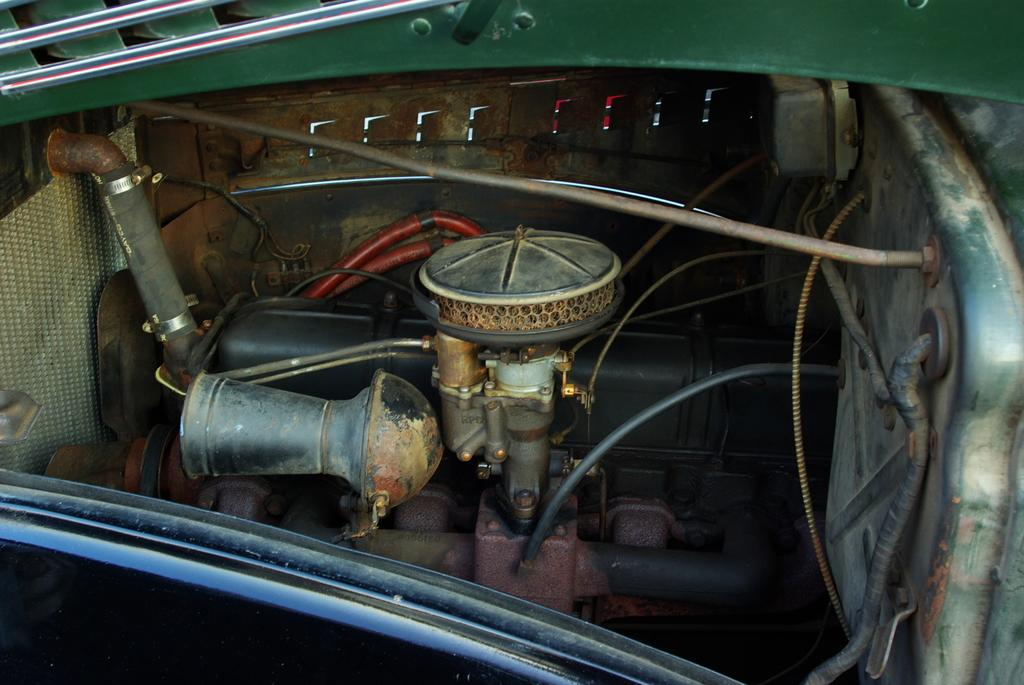What is the main subject of the image? The main subject of the image is an engine of a car. Can you describe another component visible in the image? Yes, there is a radiator on the right side of the image. What type of crayon is being used to draw on the engine in the image? There is no crayon or drawing present on the engine in the image. Who is participating in the competition involving the engine in the image? There is no competition or person involved in the image. 